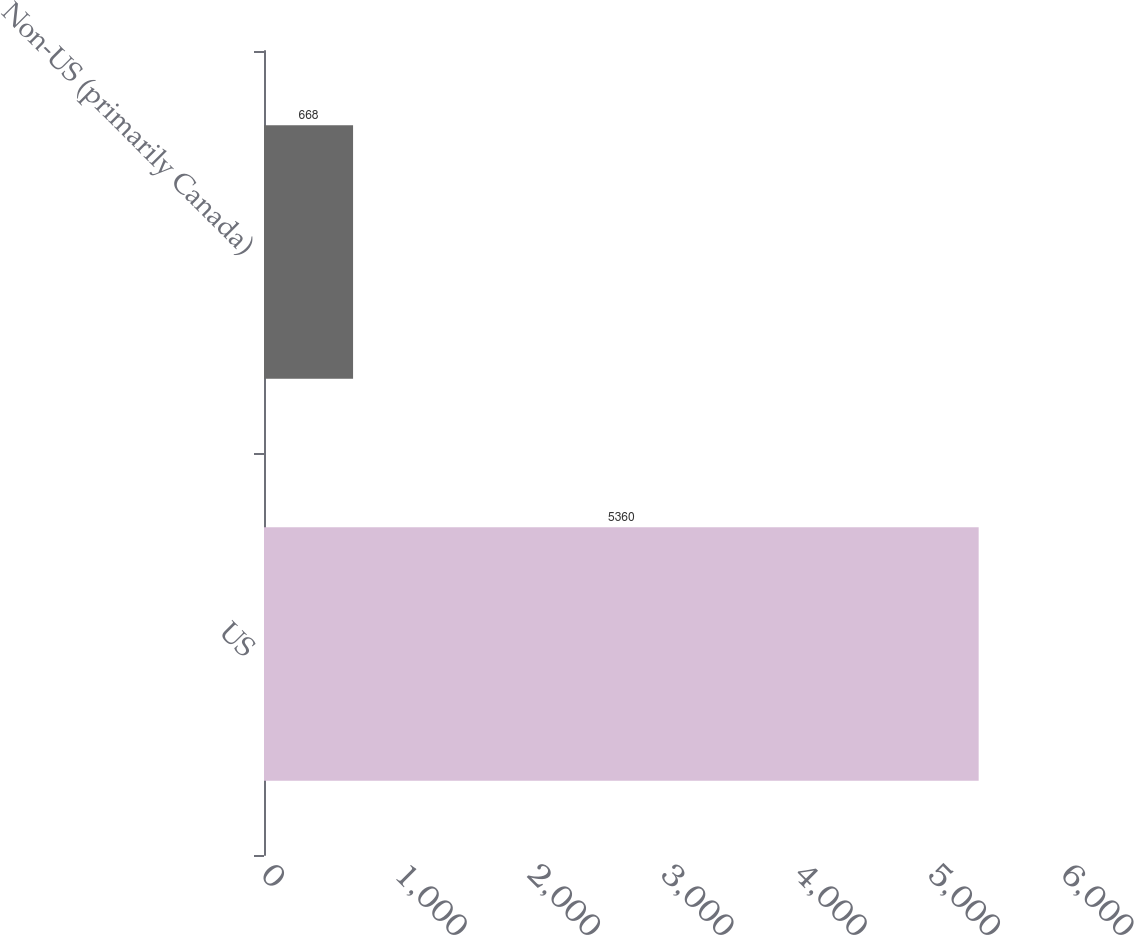<chart> <loc_0><loc_0><loc_500><loc_500><bar_chart><fcel>US<fcel>Non-US (primarily Canada)<nl><fcel>5360<fcel>668<nl></chart> 